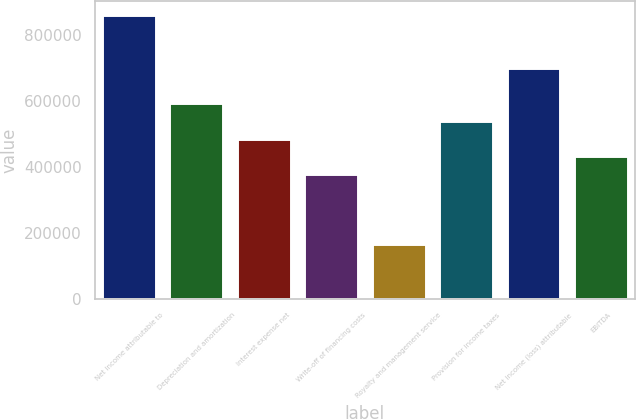<chart> <loc_0><loc_0><loc_500><loc_500><bar_chart><fcel>Net income attributable to<fcel>Depreciation and amortization<fcel>Interest expense net<fcel>Write-off of financing costs<fcel>Royalty and management service<fcel>Provision for income taxes<fcel>Net income (loss) attributable<fcel>EBITDA<nl><fcel>859911<fcel>592796<fcel>485950<fcel>379104<fcel>165412<fcel>539373<fcel>699642<fcel>432527<nl></chart> 